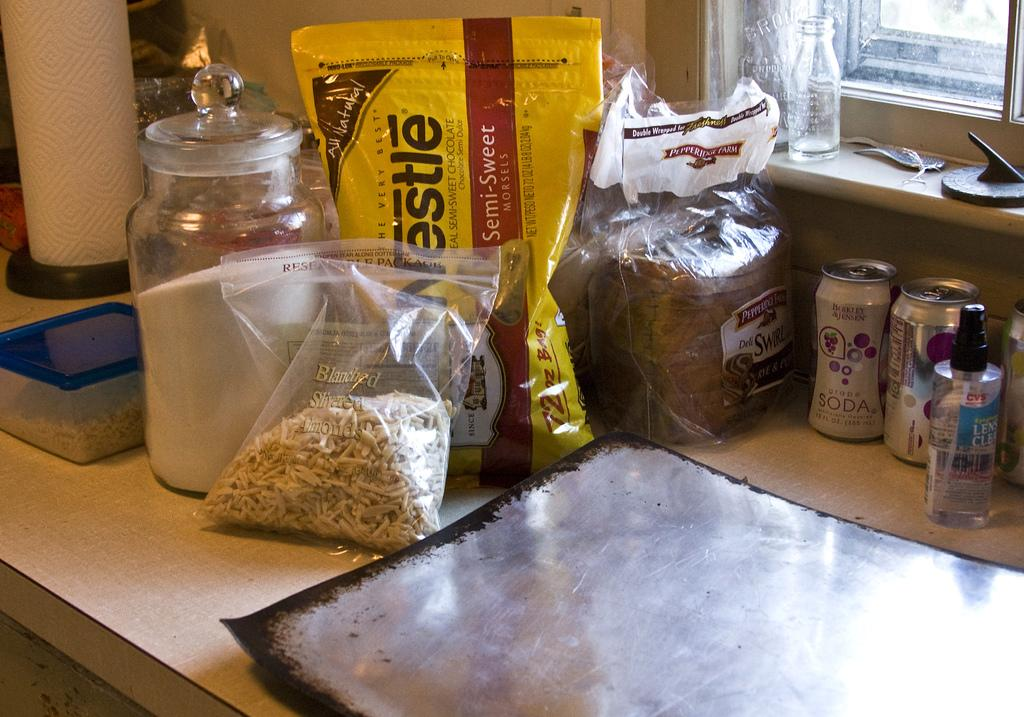What types of containers are on the table in the image? There are tins, food covers, a jar, a box, and bottles on the table in the image. What might be used to protect food from contaminants or insects? Food covers are on the table, which might be used to protect food. What other object can be seen on the table? There is a jar on the table. What type of container is the box? The box is a container that can hold various items. Is there any source of natural light visible in the image? Yes, there is a window in the image. How many clocks are visible on the table in the image? There are no clocks visible on the table in the image. What type of pipe can be seen connecting the jar and the box in the image? There is no pipe connecting the jar and the box in the image; they are separate objects on the table. 